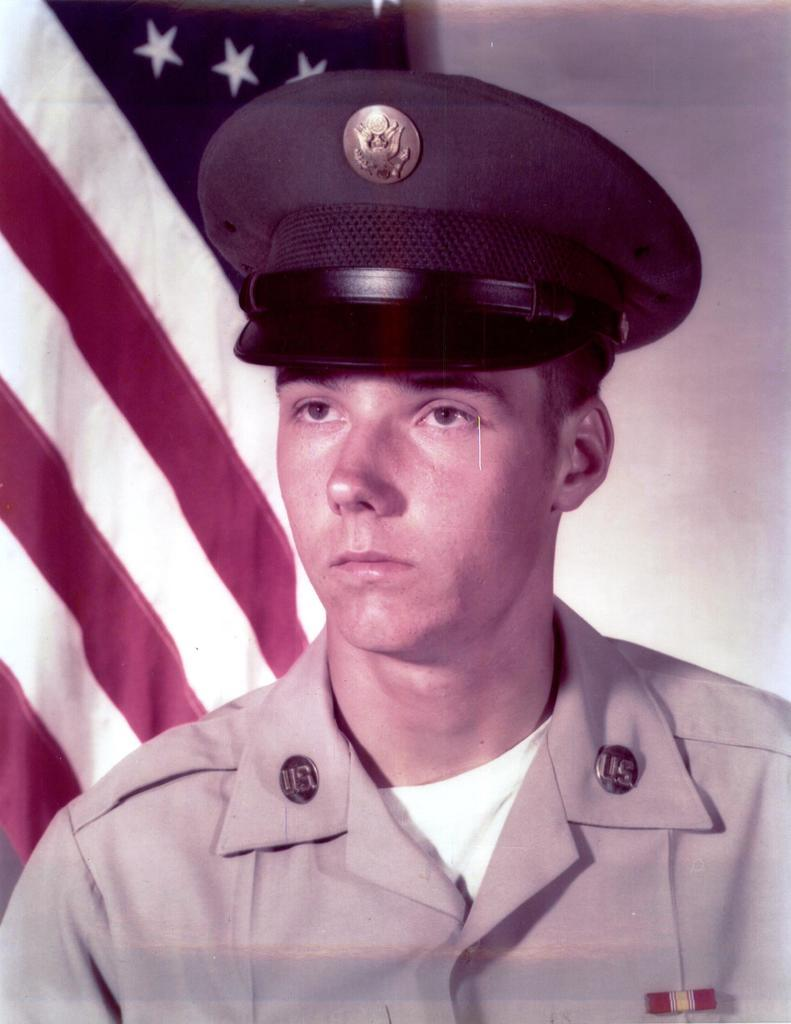Who is present in the image? There is a person in the image. What is the person wearing on their head? The person is wearing a cap. What can be seen in the background of the image? There is a flag and a wall in the background of the image. How many years of experience does the person have in honey production? There is no information about honey production or the person's experience in the image, so this question cannot be answered. 